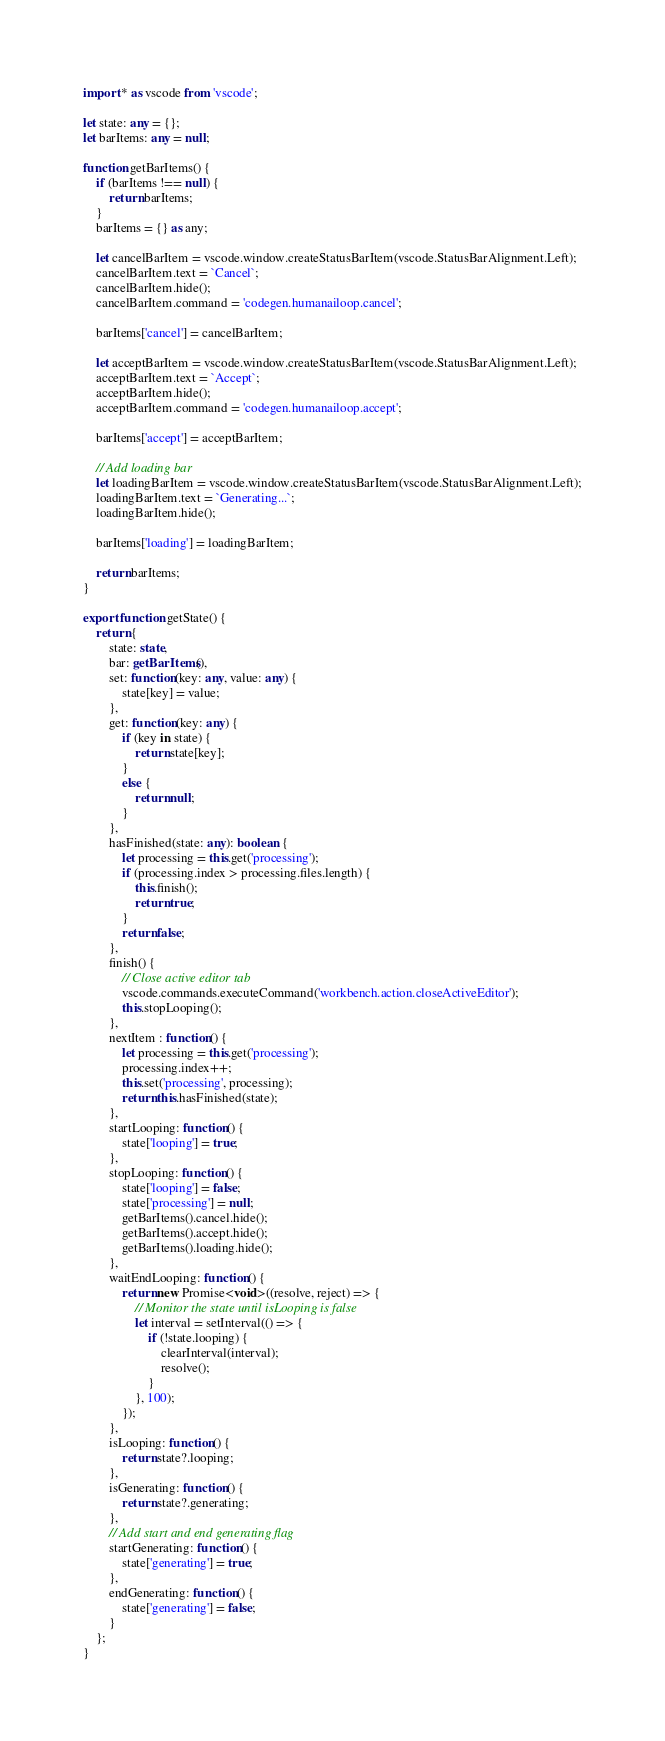<code> <loc_0><loc_0><loc_500><loc_500><_TypeScript_>import * as vscode from 'vscode';

let state: any = {};
let barItems: any = null;

function getBarItems() {
	if (barItems !== null) {
		return barItems;
	}
	barItems = {} as any;

	let cancelBarItem = vscode.window.createStatusBarItem(vscode.StatusBarAlignment.Left);
	cancelBarItem.text = `Cancel`;
	cancelBarItem.hide();
	cancelBarItem.command = 'codegen.humanailoop.cancel';

	barItems['cancel'] = cancelBarItem;

	let acceptBarItem = vscode.window.createStatusBarItem(vscode.StatusBarAlignment.Left);
	acceptBarItem.text = `Accept`;
	acceptBarItem.hide();
	acceptBarItem.command = 'codegen.humanailoop.accept';

	barItems['accept'] = acceptBarItem;

	// Add loading bar
	let loadingBarItem = vscode.window.createStatusBarItem(vscode.StatusBarAlignment.Left);
	loadingBarItem.text = `Generating...`;
	loadingBarItem.hide();

	barItems['loading'] = loadingBarItem;

	return barItems;
}

export function getState() {
	return {
		state: state,
		bar: getBarItems(),
		set: function(key: any, value: any) {
			state[key] = value;
		},
		get: function(key: any) {
			if (key in state) {
				return state[key];
			}
			else {
				return null;
			}
		},
		hasFinished(state: any): boolean {
			let processing = this.get('processing');
			if (processing.index > processing.files.length) {
				this.finish();
				return true;
			}
			return false;
		},
		finish() {
			// Close active editor tab
			vscode.commands.executeCommand('workbench.action.closeActiveEditor');
			this.stopLooping();
		},
		nextItem : function() {
			let processing = this.get('processing');
			processing.index++;
			this.set('processing', processing);
			return this.hasFinished(state);
		},
		startLooping: function() {
			state['looping'] = true;
		},
		stopLooping: function() {
			state['looping'] = false;
			state['processing'] = null;
			getBarItems().cancel.hide();
			getBarItems().accept.hide();
			getBarItems().loading.hide();
		},
		waitEndLooping: function() {
			return new Promise<void>((resolve, reject) => {
				// Monitor the state until isLooping is false
				let interval = setInterval(() => {
					if (!state.looping) {
						clearInterval(interval);
						resolve();
					}
				}, 100);
			});
		},
		isLooping: function() {
			return state?.looping;
		},
		isGenerating: function() {
			return state?.generating;
		},
		// Add start and end generating flag
		startGenerating: function() {
			state['generating'] = true;
		},
		endGenerating: function() {
			state['generating'] = false;
		}
	};
}</code> 